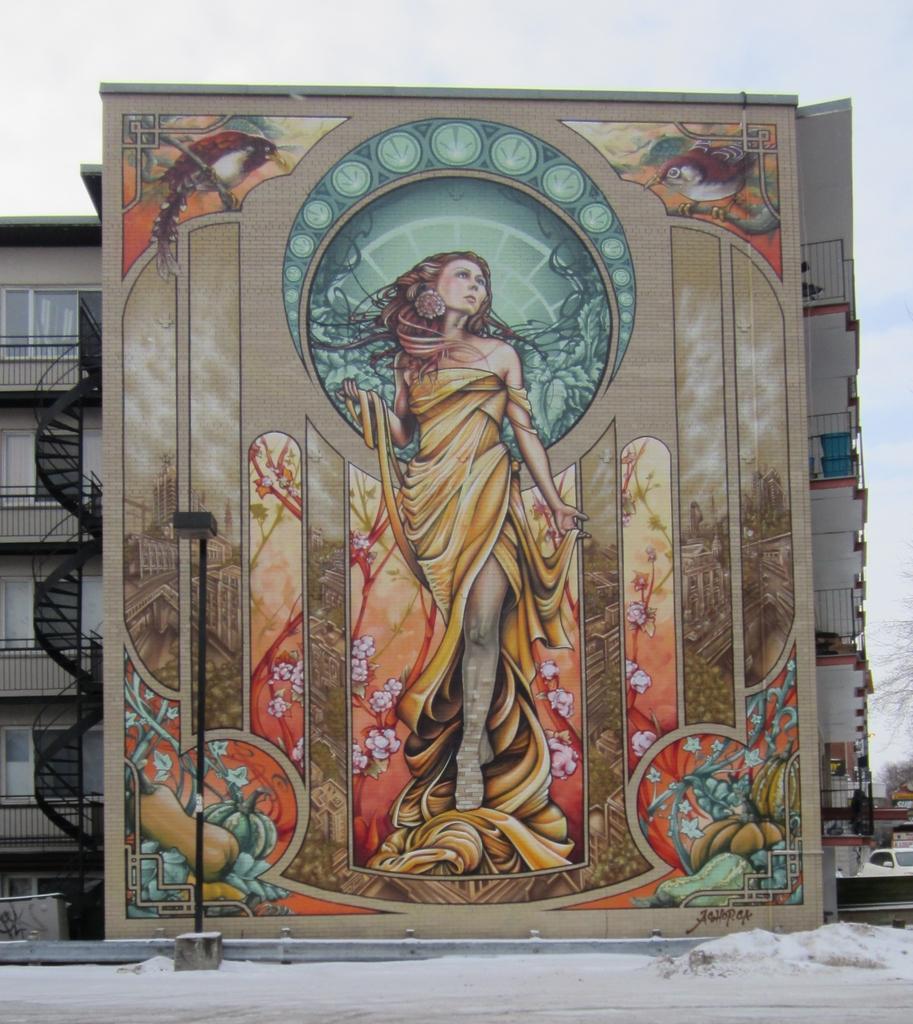Could you give a brief overview of what you see in this image? In this picture we can see a painting, in front of the painting we can find a pole and snow, in the background we can see metal rods and buildings, and also we can see vehicles. 